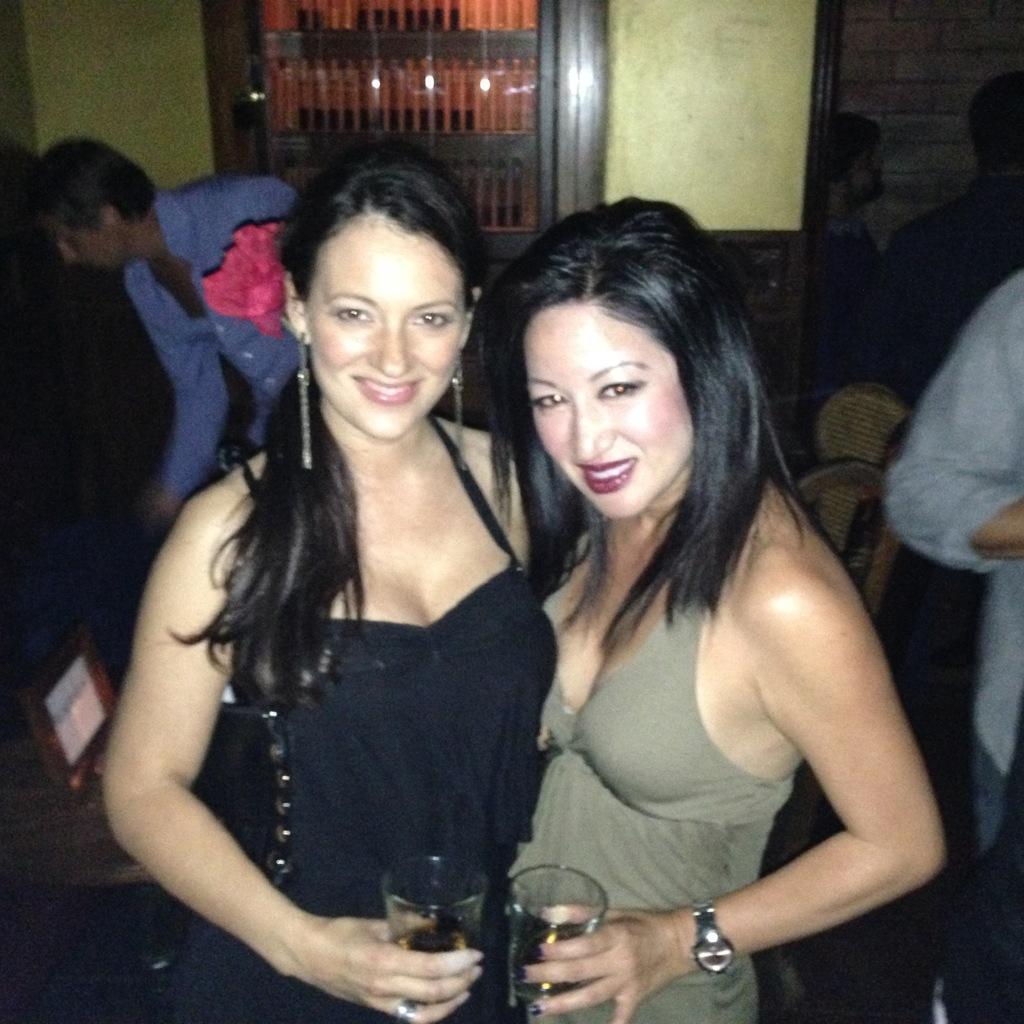In one or two sentences, can you explain what this image depicts? In this image we can see there are women holding glasses. There are people and chairs. There are objects in the cupboard. 